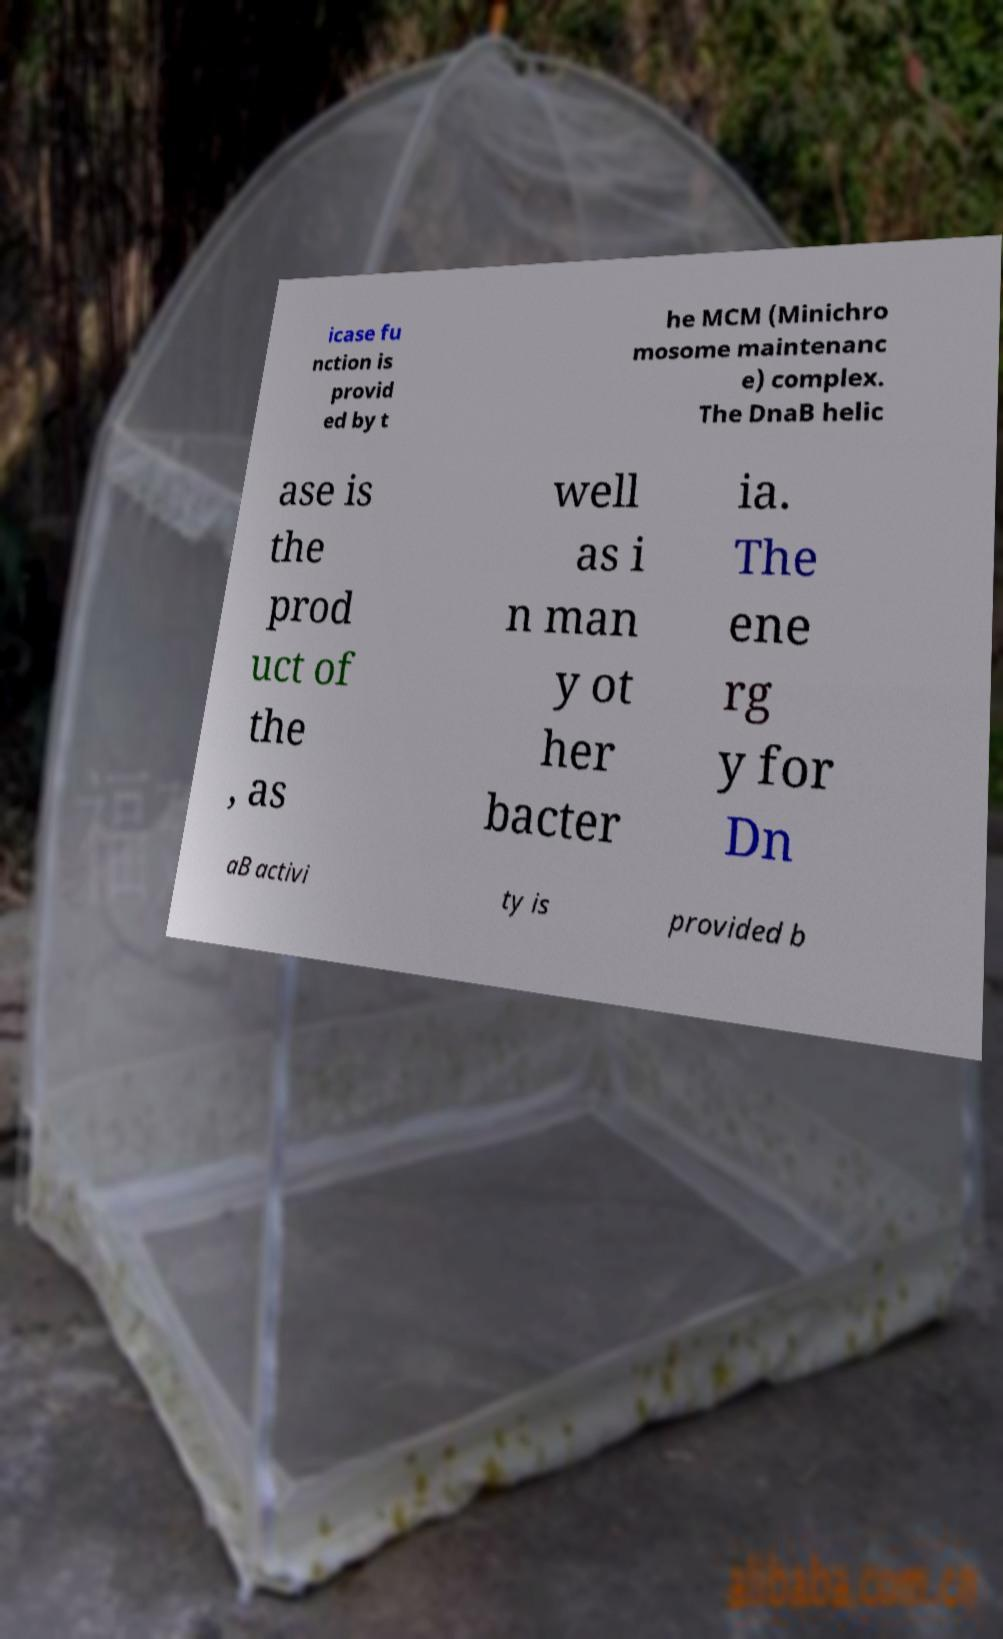Could you extract and type out the text from this image? icase fu nction is provid ed by t he MCM (Minichro mosome maintenanc e) complex. The DnaB helic ase is the prod uct of the , as well as i n man y ot her bacter ia. The ene rg y for Dn aB activi ty is provided b 